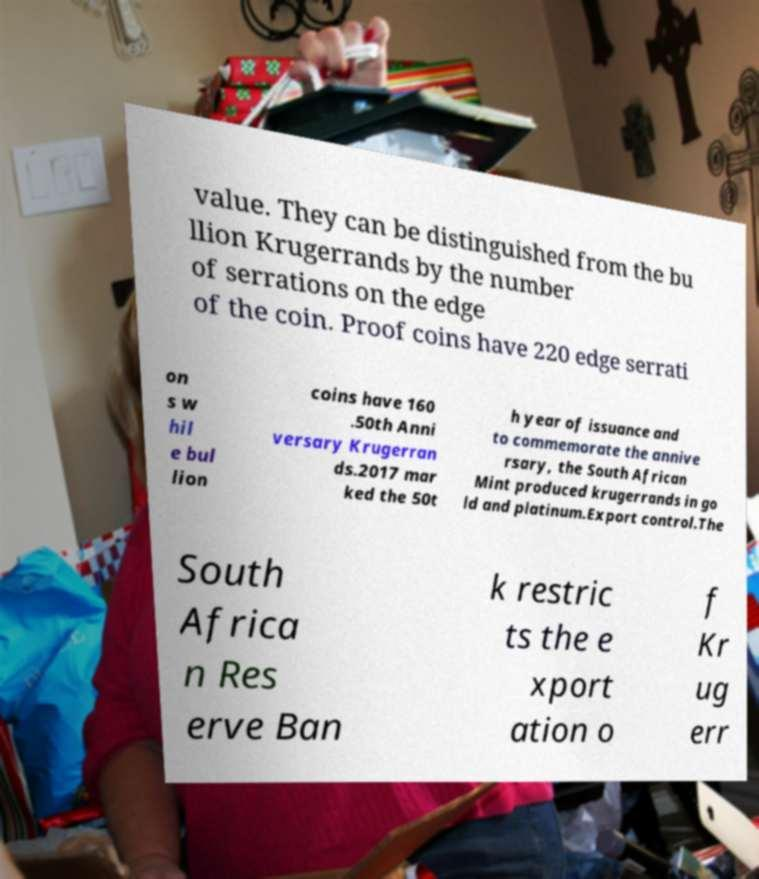For documentation purposes, I need the text within this image transcribed. Could you provide that? value. They can be distinguished from the bu llion Krugerrands by the number of serrations on the edge of the coin. Proof coins have 220 edge serrati on s w hil e bul lion coins have 160 .50th Anni versary Krugerran ds.2017 mar ked the 50t h year of issuance and to commemorate the annive rsary, the South African Mint produced krugerrands in go ld and platinum.Export control.The South Africa n Res erve Ban k restric ts the e xport ation o f Kr ug err 